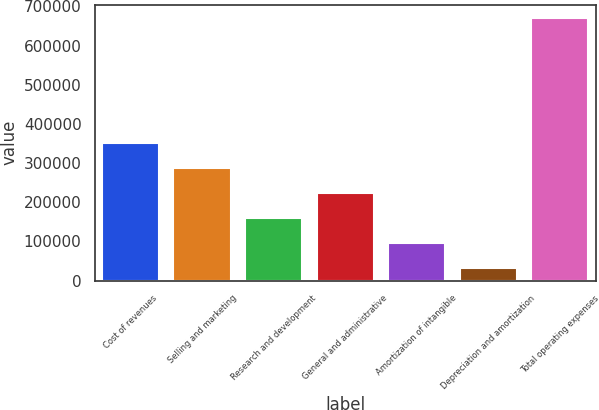<chart> <loc_0><loc_0><loc_500><loc_500><bar_chart><fcel>Cost of revenues<fcel>Selling and marketing<fcel>Research and development<fcel>General and administrative<fcel>Amortization of intangible<fcel>Depreciation and amortization<fcel>Total operating expenses<nl><fcel>351002<fcel>286979<fcel>158934<fcel>222957<fcel>94911.6<fcel>30889<fcel>671115<nl></chart> 